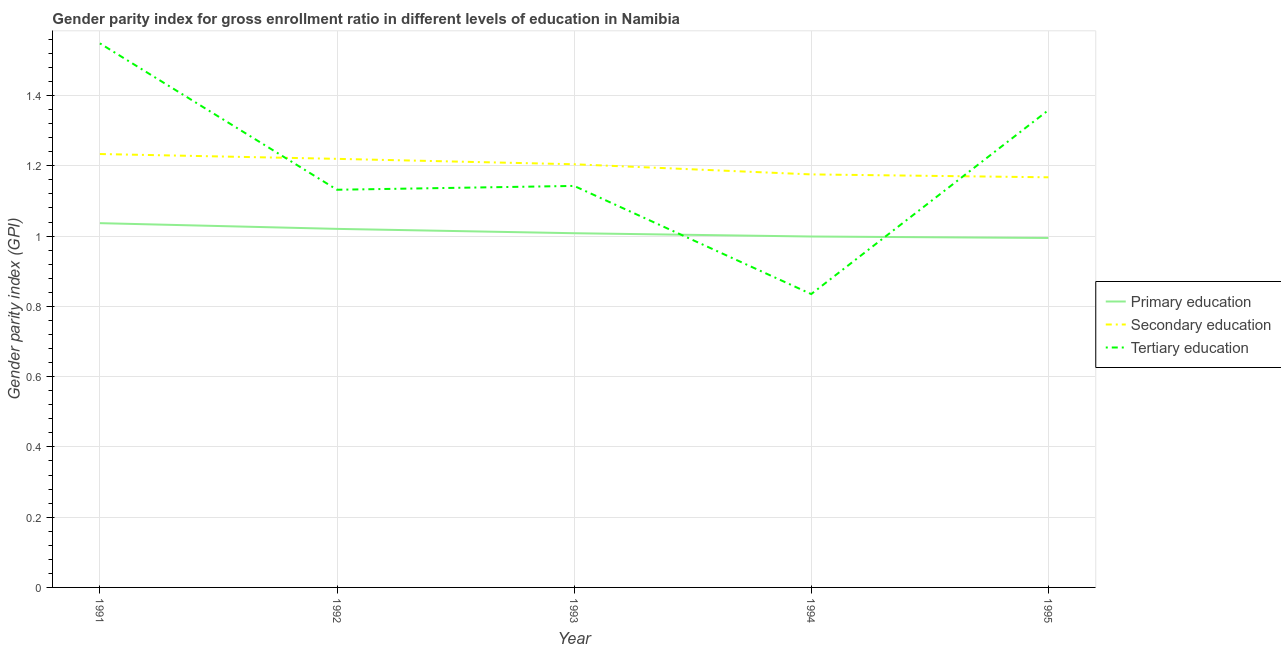How many different coloured lines are there?
Keep it short and to the point. 3. Does the line corresponding to gender parity index in tertiary education intersect with the line corresponding to gender parity index in secondary education?
Provide a succinct answer. Yes. Is the number of lines equal to the number of legend labels?
Your response must be concise. Yes. What is the gender parity index in tertiary education in 1995?
Your answer should be compact. 1.36. Across all years, what is the maximum gender parity index in tertiary education?
Offer a very short reply. 1.55. Across all years, what is the minimum gender parity index in tertiary education?
Keep it short and to the point. 0.83. In which year was the gender parity index in tertiary education minimum?
Provide a succinct answer. 1994. What is the total gender parity index in secondary education in the graph?
Provide a succinct answer. 6. What is the difference between the gender parity index in primary education in 1993 and that in 1995?
Provide a short and direct response. 0.01. What is the difference between the gender parity index in primary education in 1995 and the gender parity index in secondary education in 1992?
Give a very brief answer. -0.23. What is the average gender parity index in tertiary education per year?
Ensure brevity in your answer.  1.2. In the year 1992, what is the difference between the gender parity index in secondary education and gender parity index in tertiary education?
Ensure brevity in your answer.  0.09. What is the ratio of the gender parity index in tertiary education in 1993 to that in 1995?
Provide a short and direct response. 0.84. What is the difference between the highest and the second highest gender parity index in primary education?
Offer a very short reply. 0.02. What is the difference between the highest and the lowest gender parity index in tertiary education?
Offer a very short reply. 0.71. Is the sum of the gender parity index in primary education in 1991 and 1992 greater than the maximum gender parity index in secondary education across all years?
Provide a succinct answer. Yes. Does the gender parity index in primary education monotonically increase over the years?
Offer a terse response. No. Is the gender parity index in primary education strictly less than the gender parity index in secondary education over the years?
Make the answer very short. Yes. How many years are there in the graph?
Make the answer very short. 5. Are the values on the major ticks of Y-axis written in scientific E-notation?
Make the answer very short. No. Does the graph contain any zero values?
Provide a short and direct response. No. How are the legend labels stacked?
Your answer should be very brief. Vertical. What is the title of the graph?
Give a very brief answer. Gender parity index for gross enrollment ratio in different levels of education in Namibia. Does "Resident buildings and public services" appear as one of the legend labels in the graph?
Offer a very short reply. No. What is the label or title of the Y-axis?
Give a very brief answer. Gender parity index (GPI). What is the Gender parity index (GPI) in Primary education in 1991?
Keep it short and to the point. 1.04. What is the Gender parity index (GPI) of Secondary education in 1991?
Make the answer very short. 1.23. What is the Gender parity index (GPI) of Tertiary education in 1991?
Your answer should be compact. 1.55. What is the Gender parity index (GPI) in Primary education in 1992?
Ensure brevity in your answer.  1.02. What is the Gender parity index (GPI) of Secondary education in 1992?
Your response must be concise. 1.22. What is the Gender parity index (GPI) in Tertiary education in 1992?
Keep it short and to the point. 1.13. What is the Gender parity index (GPI) in Primary education in 1993?
Offer a very short reply. 1.01. What is the Gender parity index (GPI) of Secondary education in 1993?
Your answer should be very brief. 1.2. What is the Gender parity index (GPI) of Tertiary education in 1993?
Offer a very short reply. 1.14. What is the Gender parity index (GPI) in Secondary education in 1994?
Offer a terse response. 1.18. What is the Gender parity index (GPI) in Tertiary education in 1994?
Offer a terse response. 0.83. What is the Gender parity index (GPI) in Primary education in 1995?
Provide a short and direct response. 0.99. What is the Gender parity index (GPI) of Secondary education in 1995?
Make the answer very short. 1.17. What is the Gender parity index (GPI) of Tertiary education in 1995?
Provide a succinct answer. 1.36. Across all years, what is the maximum Gender parity index (GPI) of Primary education?
Keep it short and to the point. 1.04. Across all years, what is the maximum Gender parity index (GPI) in Secondary education?
Your answer should be very brief. 1.23. Across all years, what is the maximum Gender parity index (GPI) in Tertiary education?
Keep it short and to the point. 1.55. Across all years, what is the minimum Gender parity index (GPI) of Primary education?
Ensure brevity in your answer.  0.99. Across all years, what is the minimum Gender parity index (GPI) in Secondary education?
Ensure brevity in your answer.  1.17. Across all years, what is the minimum Gender parity index (GPI) of Tertiary education?
Keep it short and to the point. 0.83. What is the total Gender parity index (GPI) in Primary education in the graph?
Keep it short and to the point. 5.06. What is the total Gender parity index (GPI) in Secondary education in the graph?
Offer a very short reply. 6. What is the total Gender parity index (GPI) in Tertiary education in the graph?
Offer a very short reply. 6.02. What is the difference between the Gender parity index (GPI) in Primary education in 1991 and that in 1992?
Make the answer very short. 0.02. What is the difference between the Gender parity index (GPI) in Secondary education in 1991 and that in 1992?
Offer a terse response. 0.01. What is the difference between the Gender parity index (GPI) in Tertiary education in 1991 and that in 1992?
Provide a succinct answer. 0.42. What is the difference between the Gender parity index (GPI) in Primary education in 1991 and that in 1993?
Your answer should be compact. 0.03. What is the difference between the Gender parity index (GPI) in Secondary education in 1991 and that in 1993?
Keep it short and to the point. 0.03. What is the difference between the Gender parity index (GPI) in Tertiary education in 1991 and that in 1993?
Provide a succinct answer. 0.41. What is the difference between the Gender parity index (GPI) in Primary education in 1991 and that in 1994?
Keep it short and to the point. 0.04. What is the difference between the Gender parity index (GPI) of Secondary education in 1991 and that in 1994?
Your response must be concise. 0.06. What is the difference between the Gender parity index (GPI) of Tertiary education in 1991 and that in 1994?
Give a very brief answer. 0.71. What is the difference between the Gender parity index (GPI) in Primary education in 1991 and that in 1995?
Keep it short and to the point. 0.04. What is the difference between the Gender parity index (GPI) in Secondary education in 1991 and that in 1995?
Your answer should be very brief. 0.07. What is the difference between the Gender parity index (GPI) of Tertiary education in 1991 and that in 1995?
Offer a terse response. 0.19. What is the difference between the Gender parity index (GPI) in Primary education in 1992 and that in 1993?
Your answer should be compact. 0.01. What is the difference between the Gender parity index (GPI) of Secondary education in 1992 and that in 1993?
Your answer should be very brief. 0.02. What is the difference between the Gender parity index (GPI) of Tertiary education in 1992 and that in 1993?
Offer a very short reply. -0.01. What is the difference between the Gender parity index (GPI) in Primary education in 1992 and that in 1994?
Keep it short and to the point. 0.02. What is the difference between the Gender parity index (GPI) of Secondary education in 1992 and that in 1994?
Provide a succinct answer. 0.04. What is the difference between the Gender parity index (GPI) of Tertiary education in 1992 and that in 1994?
Keep it short and to the point. 0.3. What is the difference between the Gender parity index (GPI) in Primary education in 1992 and that in 1995?
Offer a terse response. 0.03. What is the difference between the Gender parity index (GPI) in Secondary education in 1992 and that in 1995?
Provide a succinct answer. 0.05. What is the difference between the Gender parity index (GPI) in Tertiary education in 1992 and that in 1995?
Offer a very short reply. -0.23. What is the difference between the Gender parity index (GPI) of Primary education in 1993 and that in 1994?
Your response must be concise. 0.01. What is the difference between the Gender parity index (GPI) in Secondary education in 1993 and that in 1994?
Make the answer very short. 0.03. What is the difference between the Gender parity index (GPI) in Tertiary education in 1993 and that in 1994?
Offer a very short reply. 0.31. What is the difference between the Gender parity index (GPI) of Primary education in 1993 and that in 1995?
Your answer should be compact. 0.01. What is the difference between the Gender parity index (GPI) in Secondary education in 1993 and that in 1995?
Keep it short and to the point. 0.04. What is the difference between the Gender parity index (GPI) in Tertiary education in 1993 and that in 1995?
Ensure brevity in your answer.  -0.22. What is the difference between the Gender parity index (GPI) in Primary education in 1994 and that in 1995?
Your answer should be very brief. 0. What is the difference between the Gender parity index (GPI) in Secondary education in 1994 and that in 1995?
Make the answer very short. 0.01. What is the difference between the Gender parity index (GPI) in Tertiary education in 1994 and that in 1995?
Provide a short and direct response. -0.52. What is the difference between the Gender parity index (GPI) of Primary education in 1991 and the Gender parity index (GPI) of Secondary education in 1992?
Offer a very short reply. -0.18. What is the difference between the Gender parity index (GPI) of Primary education in 1991 and the Gender parity index (GPI) of Tertiary education in 1992?
Make the answer very short. -0.1. What is the difference between the Gender parity index (GPI) in Secondary education in 1991 and the Gender parity index (GPI) in Tertiary education in 1992?
Keep it short and to the point. 0.1. What is the difference between the Gender parity index (GPI) in Primary education in 1991 and the Gender parity index (GPI) in Secondary education in 1993?
Your answer should be very brief. -0.17. What is the difference between the Gender parity index (GPI) of Primary education in 1991 and the Gender parity index (GPI) of Tertiary education in 1993?
Your answer should be very brief. -0.11. What is the difference between the Gender parity index (GPI) in Secondary education in 1991 and the Gender parity index (GPI) in Tertiary education in 1993?
Your response must be concise. 0.09. What is the difference between the Gender parity index (GPI) of Primary education in 1991 and the Gender parity index (GPI) of Secondary education in 1994?
Offer a terse response. -0.14. What is the difference between the Gender parity index (GPI) of Primary education in 1991 and the Gender parity index (GPI) of Tertiary education in 1994?
Keep it short and to the point. 0.2. What is the difference between the Gender parity index (GPI) in Secondary education in 1991 and the Gender parity index (GPI) in Tertiary education in 1994?
Your response must be concise. 0.4. What is the difference between the Gender parity index (GPI) of Primary education in 1991 and the Gender parity index (GPI) of Secondary education in 1995?
Your response must be concise. -0.13. What is the difference between the Gender parity index (GPI) of Primary education in 1991 and the Gender parity index (GPI) of Tertiary education in 1995?
Make the answer very short. -0.32. What is the difference between the Gender parity index (GPI) of Secondary education in 1991 and the Gender parity index (GPI) of Tertiary education in 1995?
Your answer should be compact. -0.12. What is the difference between the Gender parity index (GPI) of Primary education in 1992 and the Gender parity index (GPI) of Secondary education in 1993?
Your answer should be compact. -0.18. What is the difference between the Gender parity index (GPI) in Primary education in 1992 and the Gender parity index (GPI) in Tertiary education in 1993?
Offer a very short reply. -0.12. What is the difference between the Gender parity index (GPI) in Secondary education in 1992 and the Gender parity index (GPI) in Tertiary education in 1993?
Your response must be concise. 0.08. What is the difference between the Gender parity index (GPI) in Primary education in 1992 and the Gender parity index (GPI) in Secondary education in 1994?
Make the answer very short. -0.15. What is the difference between the Gender parity index (GPI) in Primary education in 1992 and the Gender parity index (GPI) in Tertiary education in 1994?
Offer a terse response. 0.19. What is the difference between the Gender parity index (GPI) in Secondary education in 1992 and the Gender parity index (GPI) in Tertiary education in 1994?
Make the answer very short. 0.38. What is the difference between the Gender parity index (GPI) in Primary education in 1992 and the Gender parity index (GPI) in Secondary education in 1995?
Ensure brevity in your answer.  -0.15. What is the difference between the Gender parity index (GPI) of Primary education in 1992 and the Gender parity index (GPI) of Tertiary education in 1995?
Ensure brevity in your answer.  -0.34. What is the difference between the Gender parity index (GPI) in Secondary education in 1992 and the Gender parity index (GPI) in Tertiary education in 1995?
Make the answer very short. -0.14. What is the difference between the Gender parity index (GPI) of Primary education in 1993 and the Gender parity index (GPI) of Secondary education in 1994?
Your answer should be compact. -0.17. What is the difference between the Gender parity index (GPI) in Primary education in 1993 and the Gender parity index (GPI) in Tertiary education in 1994?
Keep it short and to the point. 0.17. What is the difference between the Gender parity index (GPI) of Secondary education in 1993 and the Gender parity index (GPI) of Tertiary education in 1994?
Give a very brief answer. 0.37. What is the difference between the Gender parity index (GPI) in Primary education in 1993 and the Gender parity index (GPI) in Secondary education in 1995?
Offer a very short reply. -0.16. What is the difference between the Gender parity index (GPI) in Primary education in 1993 and the Gender parity index (GPI) in Tertiary education in 1995?
Ensure brevity in your answer.  -0.35. What is the difference between the Gender parity index (GPI) of Secondary education in 1993 and the Gender parity index (GPI) of Tertiary education in 1995?
Give a very brief answer. -0.15. What is the difference between the Gender parity index (GPI) in Primary education in 1994 and the Gender parity index (GPI) in Secondary education in 1995?
Offer a terse response. -0.17. What is the difference between the Gender parity index (GPI) in Primary education in 1994 and the Gender parity index (GPI) in Tertiary education in 1995?
Your response must be concise. -0.36. What is the difference between the Gender parity index (GPI) of Secondary education in 1994 and the Gender parity index (GPI) of Tertiary education in 1995?
Your answer should be compact. -0.18. What is the average Gender parity index (GPI) of Primary education per year?
Provide a succinct answer. 1.01. What is the average Gender parity index (GPI) of Secondary education per year?
Offer a terse response. 1.2. What is the average Gender parity index (GPI) of Tertiary education per year?
Offer a very short reply. 1.2. In the year 1991, what is the difference between the Gender parity index (GPI) in Primary education and Gender parity index (GPI) in Secondary education?
Make the answer very short. -0.2. In the year 1991, what is the difference between the Gender parity index (GPI) of Primary education and Gender parity index (GPI) of Tertiary education?
Your answer should be compact. -0.51. In the year 1991, what is the difference between the Gender parity index (GPI) of Secondary education and Gender parity index (GPI) of Tertiary education?
Ensure brevity in your answer.  -0.31. In the year 1992, what is the difference between the Gender parity index (GPI) in Primary education and Gender parity index (GPI) in Secondary education?
Give a very brief answer. -0.2. In the year 1992, what is the difference between the Gender parity index (GPI) in Primary education and Gender parity index (GPI) in Tertiary education?
Give a very brief answer. -0.11. In the year 1992, what is the difference between the Gender parity index (GPI) in Secondary education and Gender parity index (GPI) in Tertiary education?
Offer a terse response. 0.09. In the year 1993, what is the difference between the Gender parity index (GPI) of Primary education and Gender parity index (GPI) of Secondary education?
Your answer should be very brief. -0.2. In the year 1993, what is the difference between the Gender parity index (GPI) of Primary education and Gender parity index (GPI) of Tertiary education?
Ensure brevity in your answer.  -0.13. In the year 1993, what is the difference between the Gender parity index (GPI) of Secondary education and Gender parity index (GPI) of Tertiary education?
Keep it short and to the point. 0.06. In the year 1994, what is the difference between the Gender parity index (GPI) in Primary education and Gender parity index (GPI) in Secondary education?
Ensure brevity in your answer.  -0.18. In the year 1994, what is the difference between the Gender parity index (GPI) of Primary education and Gender parity index (GPI) of Tertiary education?
Offer a terse response. 0.16. In the year 1994, what is the difference between the Gender parity index (GPI) of Secondary education and Gender parity index (GPI) of Tertiary education?
Make the answer very short. 0.34. In the year 1995, what is the difference between the Gender parity index (GPI) of Primary education and Gender parity index (GPI) of Secondary education?
Make the answer very short. -0.17. In the year 1995, what is the difference between the Gender parity index (GPI) of Primary education and Gender parity index (GPI) of Tertiary education?
Offer a very short reply. -0.36. In the year 1995, what is the difference between the Gender parity index (GPI) in Secondary education and Gender parity index (GPI) in Tertiary education?
Offer a terse response. -0.19. What is the ratio of the Gender parity index (GPI) in Primary education in 1991 to that in 1992?
Keep it short and to the point. 1.02. What is the ratio of the Gender parity index (GPI) in Secondary education in 1991 to that in 1992?
Offer a very short reply. 1.01. What is the ratio of the Gender parity index (GPI) of Tertiary education in 1991 to that in 1992?
Your response must be concise. 1.37. What is the ratio of the Gender parity index (GPI) of Primary education in 1991 to that in 1993?
Provide a short and direct response. 1.03. What is the ratio of the Gender parity index (GPI) of Secondary education in 1991 to that in 1993?
Provide a short and direct response. 1.02. What is the ratio of the Gender parity index (GPI) of Tertiary education in 1991 to that in 1993?
Keep it short and to the point. 1.35. What is the ratio of the Gender parity index (GPI) in Primary education in 1991 to that in 1994?
Your answer should be very brief. 1.04. What is the ratio of the Gender parity index (GPI) of Secondary education in 1991 to that in 1994?
Your answer should be compact. 1.05. What is the ratio of the Gender parity index (GPI) of Tertiary education in 1991 to that in 1994?
Ensure brevity in your answer.  1.85. What is the ratio of the Gender parity index (GPI) in Primary education in 1991 to that in 1995?
Keep it short and to the point. 1.04. What is the ratio of the Gender parity index (GPI) of Secondary education in 1991 to that in 1995?
Make the answer very short. 1.06. What is the ratio of the Gender parity index (GPI) in Tertiary education in 1991 to that in 1995?
Offer a terse response. 1.14. What is the ratio of the Gender parity index (GPI) of Primary education in 1992 to that in 1993?
Give a very brief answer. 1.01. What is the ratio of the Gender parity index (GPI) of Secondary education in 1992 to that in 1993?
Your answer should be compact. 1.01. What is the ratio of the Gender parity index (GPI) of Primary education in 1992 to that in 1994?
Your response must be concise. 1.02. What is the ratio of the Gender parity index (GPI) in Secondary education in 1992 to that in 1994?
Offer a very short reply. 1.04. What is the ratio of the Gender parity index (GPI) in Tertiary education in 1992 to that in 1994?
Ensure brevity in your answer.  1.36. What is the ratio of the Gender parity index (GPI) in Secondary education in 1992 to that in 1995?
Offer a very short reply. 1.04. What is the ratio of the Gender parity index (GPI) of Primary education in 1993 to that in 1994?
Keep it short and to the point. 1.01. What is the ratio of the Gender parity index (GPI) in Secondary education in 1993 to that in 1994?
Provide a short and direct response. 1.02. What is the ratio of the Gender parity index (GPI) in Tertiary education in 1993 to that in 1994?
Ensure brevity in your answer.  1.37. What is the ratio of the Gender parity index (GPI) in Primary education in 1993 to that in 1995?
Provide a short and direct response. 1.01. What is the ratio of the Gender parity index (GPI) of Secondary education in 1993 to that in 1995?
Provide a succinct answer. 1.03. What is the ratio of the Gender parity index (GPI) of Tertiary education in 1993 to that in 1995?
Your answer should be compact. 0.84. What is the ratio of the Gender parity index (GPI) of Primary education in 1994 to that in 1995?
Give a very brief answer. 1. What is the ratio of the Gender parity index (GPI) of Secondary education in 1994 to that in 1995?
Provide a succinct answer. 1.01. What is the ratio of the Gender parity index (GPI) of Tertiary education in 1994 to that in 1995?
Your response must be concise. 0.61. What is the difference between the highest and the second highest Gender parity index (GPI) in Primary education?
Your response must be concise. 0.02. What is the difference between the highest and the second highest Gender parity index (GPI) in Secondary education?
Provide a succinct answer. 0.01. What is the difference between the highest and the second highest Gender parity index (GPI) of Tertiary education?
Offer a very short reply. 0.19. What is the difference between the highest and the lowest Gender parity index (GPI) of Primary education?
Offer a terse response. 0.04. What is the difference between the highest and the lowest Gender parity index (GPI) of Secondary education?
Make the answer very short. 0.07. What is the difference between the highest and the lowest Gender parity index (GPI) in Tertiary education?
Ensure brevity in your answer.  0.71. 